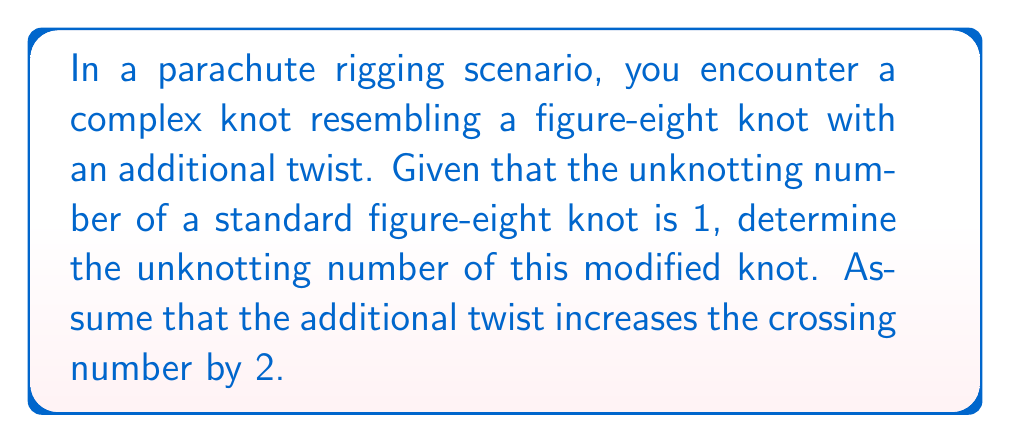Show me your answer to this math problem. Let's approach this step-by-step:

1) First, recall that the unknotting number is the minimum number of crossing changes required to transform a knot into the unknot (trivial knot).

2) A standard figure-eight knot has an unknotting number of 1. This means one crossing change is sufficient to unknot it.

3) The additional twist in our modified knot increases the crossing number by 2. This means we now have two more crossings to consider.

4) In knot theory, we use the following inequality:

   $$u(K) \leq \frac{c(K)}{2}$$

   where $u(K)$ is the unknotting number and $c(K)$ is the crossing number.

5) For a standard figure-eight knot, $c(K) = 4$ and $u(K) = 1$.

6) In our modified knot, $c(K) = 6$ (4 from the original figure-eight + 2 from the additional twist).

7) Using the inequality:

   $$u(K) \leq \frac{6}{2} = 3$$

8) However, we know that the original figure-eight part can be unknotted with one move. The additional twist might require at most one more move.

9) Therefore, the unknotting number of our modified knot is at most 2.

10) Given the veteran's experience with parachute rigging, it's likely that this is indeed the minimum number of moves required.
Answer: 2 